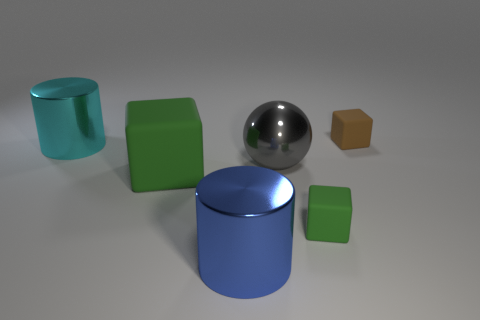Is the shape of the big green thing the same as the tiny brown matte object?
Give a very brief answer. Yes. What number of big gray metallic objects are behind the small rubber thing that is behind the cyan object on the left side of the small green block?
Ensure brevity in your answer.  0. What shape is the large object that is the same material as the small brown block?
Make the answer very short. Cube. There is a big cylinder that is in front of the green rubber cube that is behind the small matte object that is in front of the cyan metallic object; what is its material?
Your answer should be compact. Metal. What number of objects are either large gray metallic spheres on the left side of the brown rubber thing or yellow matte objects?
Keep it short and to the point. 1. What number of other things are the same shape as the brown rubber object?
Offer a terse response. 2. Are there more things that are to the left of the small brown block than large green objects?
Offer a terse response. Yes. What is the size of the other green rubber object that is the same shape as the big green matte object?
Your answer should be very brief. Small. The cyan shiny thing is what shape?
Your response must be concise. Cylinder. There is a green matte thing that is the same size as the blue metal cylinder; what is its shape?
Keep it short and to the point. Cube. 